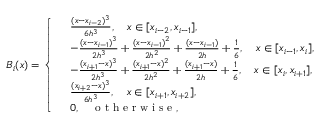Convert formula to latex. <formula><loc_0><loc_0><loc_500><loc_500>B _ { i } ( x ) = \left \{ \begin{array} { r l } & { \frac { ( x - x _ { i - 2 } ) ^ { 3 } } { 6 h ^ { 3 } } , \quad x \in [ x _ { i - 2 } , x _ { i - 1 } ] , } \\ & { - \frac { ( x - x _ { i - 1 } ) ^ { 3 } } { 2 h ^ { 3 } } + \frac { ( x - x _ { i - 1 } ) ^ { 2 } } { 2 h ^ { 2 } } + \frac { ( x - x _ { i - 1 } ) } { 2 h } + \frac { 1 } { 6 } , \quad x \in [ x _ { i - 1 } , x _ { i } ] , } \\ & { - \frac { ( x _ { i + 1 } - x ) ^ { 3 } } { 2 h ^ { 3 } } + \frac { ( x _ { i + 1 } - x ) ^ { 2 } } { 2 h ^ { 2 } } + \frac { ( x _ { i + 1 } - x ) } { 2 h } + \frac { 1 } { 6 } , \quad x \in [ x _ { i } , x _ { i + 1 } ] , } \\ & { \frac { ( x _ { i + 2 } - x ) ^ { 3 } } { 6 h ^ { 3 } } , \quad x \in [ x _ { i + 1 } , x _ { i + 2 } ] , } \\ & { 0 , \quad o t h e r w i s e , } \end{array}</formula> 